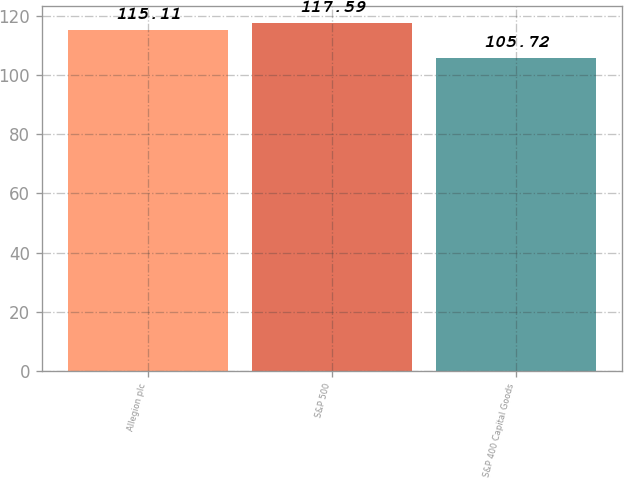<chart> <loc_0><loc_0><loc_500><loc_500><bar_chart><fcel>Allegion plc<fcel>S&P 500<fcel>S&P 400 Capital Goods<nl><fcel>115.11<fcel>117.59<fcel>105.72<nl></chart> 